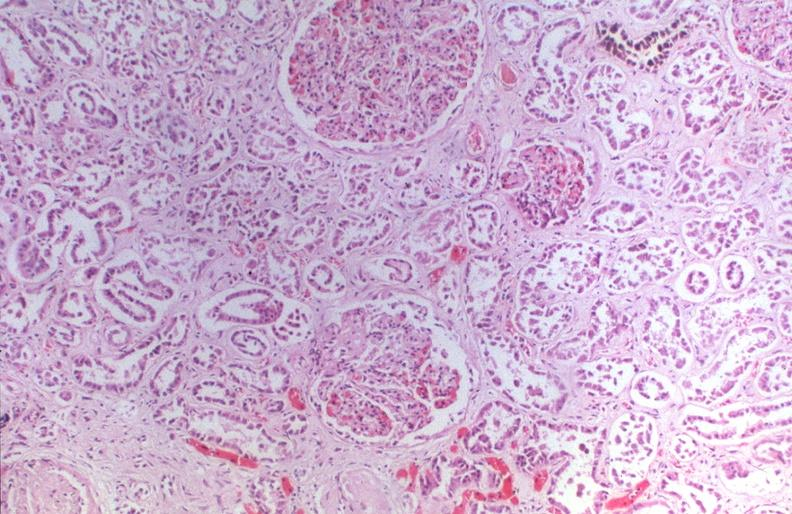does this image show kidney, hemochromatosis?
Answer the question using a single word or phrase. Yes 